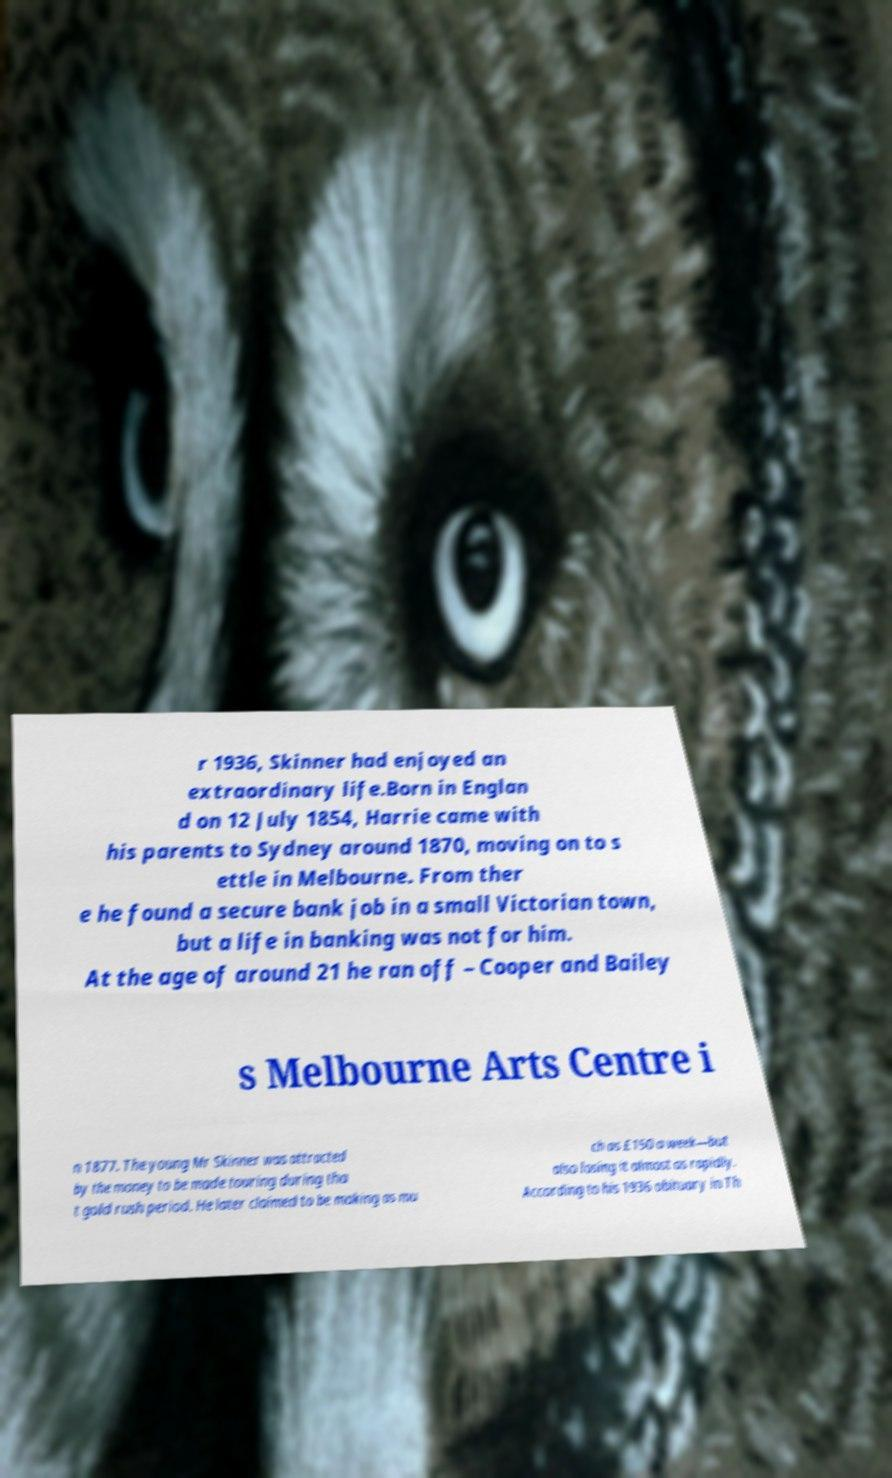There's text embedded in this image that I need extracted. Can you transcribe it verbatim? r 1936, Skinner had enjoyed an extraordinary life.Born in Englan d on 12 July 1854, Harrie came with his parents to Sydney around 1870, moving on to s ettle in Melbourne. From ther e he found a secure bank job in a small Victorian town, but a life in banking was not for him. At the age of around 21 he ran off – Cooper and Bailey s Melbourne Arts Centre i n 1877. The young Mr Skinner was attracted by the money to be made touring during tha t gold rush period. He later claimed to be making as mu ch as £150 a week—but also losing it almost as rapidly. According to his 1936 obituary in Th 